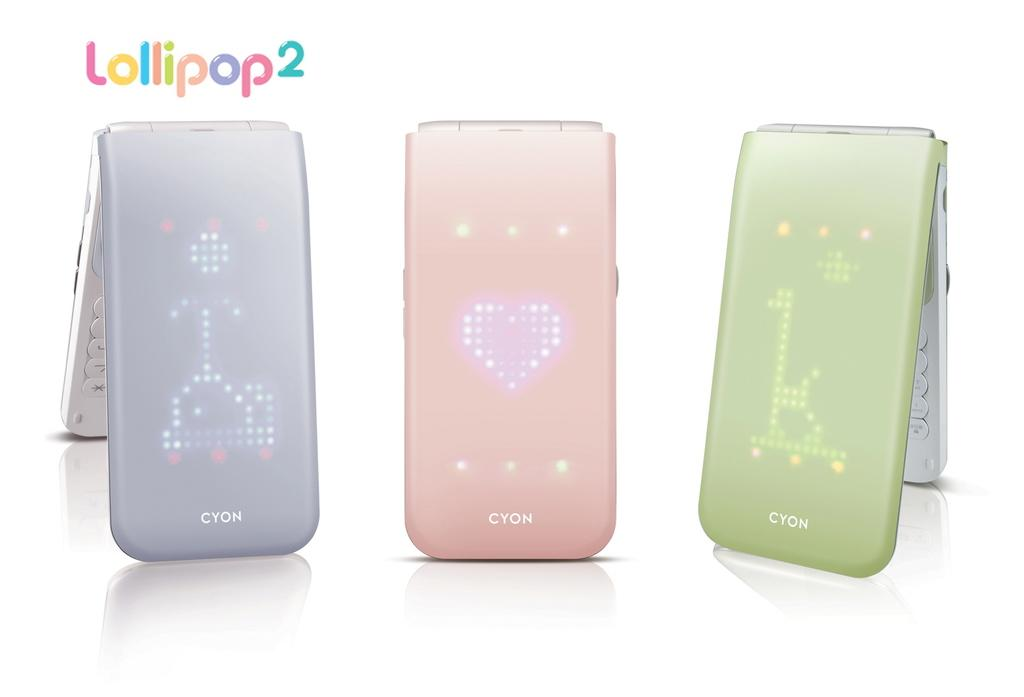<image>
Present a compact description of the photo's key features. Three Cyon phones are shown with light up patterns on the front covers. 